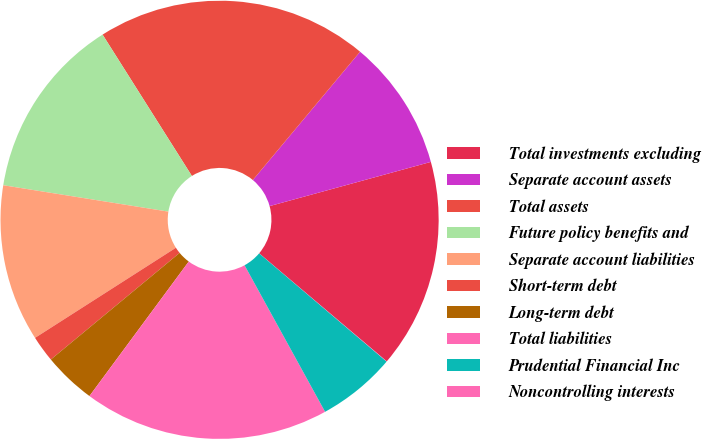Convert chart. <chart><loc_0><loc_0><loc_500><loc_500><pie_chart><fcel>Total investments excluding<fcel>Separate account assets<fcel>Total assets<fcel>Future policy benefits and<fcel>Separate account liabilities<fcel>Short-term debt<fcel>Long-term debt<fcel>Total liabilities<fcel>Prudential Financial Inc<fcel>Noncontrolling interests<nl><fcel>15.44%<fcel>9.66%<fcel>20.05%<fcel>13.51%<fcel>11.58%<fcel>1.95%<fcel>3.87%<fcel>18.12%<fcel>5.8%<fcel>0.02%<nl></chart> 